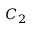<formula> <loc_0><loc_0><loc_500><loc_500>C _ { 2 }</formula> 